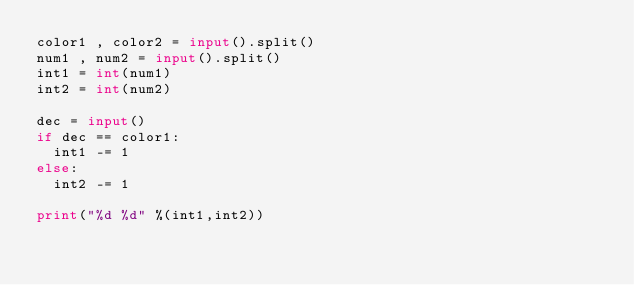Convert code to text. <code><loc_0><loc_0><loc_500><loc_500><_Python_>color1 , color2 = input().split()
num1 , num2 = input().split()
int1 = int(num1)
int2 = int(num2)

dec = input()
if dec == color1:
  int1 -= 1
else:
  int2 -= 1

print("%d %d" %(int1,int2))</code> 